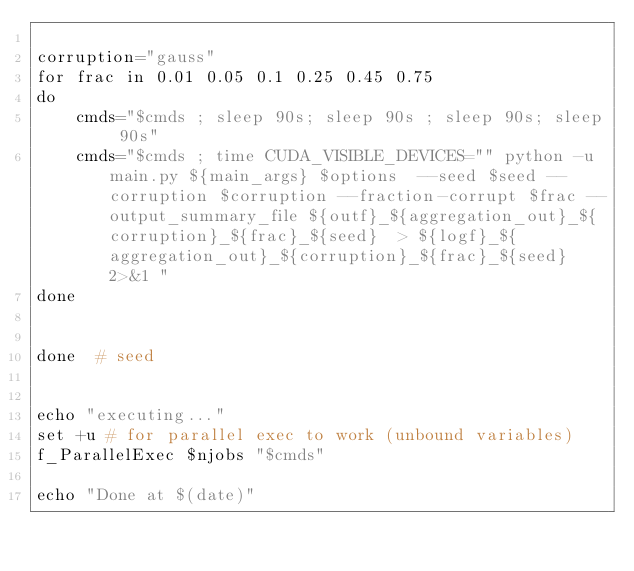<code> <loc_0><loc_0><loc_500><loc_500><_Bash_>
corruption="gauss"
for frac in 0.01 0.05 0.1 0.25 0.45 0.75
do
    cmds="$cmds ; sleep 90s; sleep 90s ; sleep 90s; sleep 90s"
    cmds="$cmds ; time CUDA_VISIBLE_DEVICES="" python -u main.py ${main_args} $options  --seed $seed --corruption $corruption --fraction-corrupt $frac --output_summary_file ${outf}_${aggregation_out}_${corruption}_${frac}_${seed}  > ${logf}_${aggregation_out}_${corruption}_${frac}_${seed} 2>&1 "
done


done  # seed


echo "executing..."
set +u # for parallel exec to work (unbound variables)
f_ParallelExec $njobs "$cmds"

echo "Done at $(date)"
</code> 